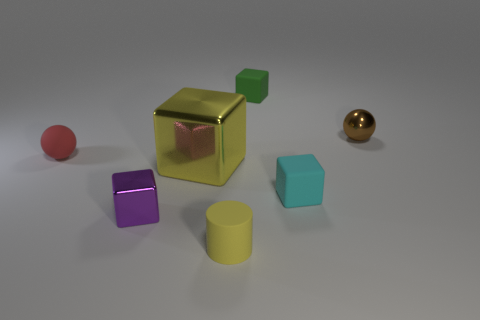Add 2 brown rubber cylinders. How many objects exist? 9 Subtract all cubes. How many objects are left? 3 Add 5 red objects. How many red objects exist? 6 Subtract 0 cyan balls. How many objects are left? 7 Subtract all purple metallic things. Subtract all small red rubber objects. How many objects are left? 5 Add 1 tiny brown metal spheres. How many tiny brown metal spheres are left? 2 